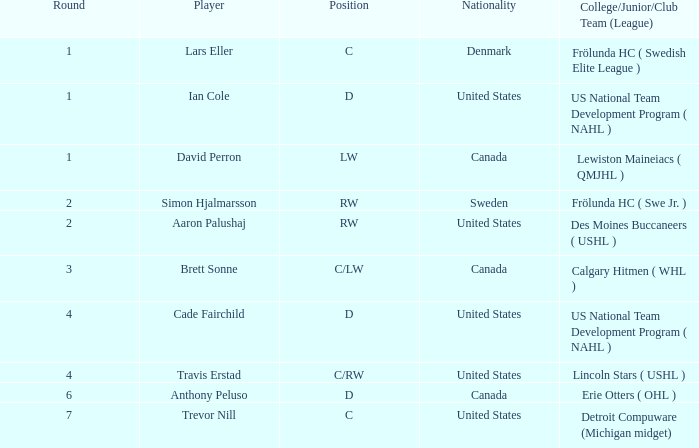Write the full table. {'header': ['Round', 'Player', 'Position', 'Nationality', 'College/Junior/Club Team (League)'], 'rows': [['1', 'Lars Eller', 'C', 'Denmark', 'Frölunda HC ( Swedish Elite League )'], ['1', 'Ian Cole', 'D', 'United States', 'US National Team Development Program ( NAHL )'], ['1', 'David Perron', 'LW', 'Canada', 'Lewiston Maineiacs ( QMJHL )'], ['2', 'Simon Hjalmarsson', 'RW', 'Sweden', 'Frölunda HC ( Swe Jr. )'], ['2', 'Aaron Palushaj', 'RW', 'United States', 'Des Moines Buccaneers ( USHL )'], ['3', 'Brett Sonne', 'C/LW', 'Canada', 'Calgary Hitmen ( WHL )'], ['4', 'Cade Fairchild', 'D', 'United States', 'US National Team Development Program ( NAHL )'], ['4', 'Travis Erstad', 'C/RW', 'United States', 'Lincoln Stars ( USHL )'], ['6', 'Anthony Peluso', 'D', 'Canada', 'Erie Otters ( OHL )'], ['7', 'Trevor Nill', 'C', 'United States', 'Detroit Compuware (Michigan midget)']]} What is the position of the player from round 2 from Sweden? RW. 